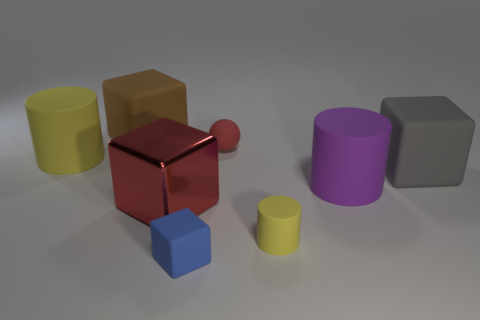Add 1 large red metal blocks. How many objects exist? 9 Subtract all spheres. How many objects are left? 7 Add 7 brown shiny spheres. How many brown shiny spheres exist? 7 Subtract 1 blue blocks. How many objects are left? 7 Subtract all small blue blocks. Subtract all small rubber balls. How many objects are left? 6 Add 4 small balls. How many small balls are left? 5 